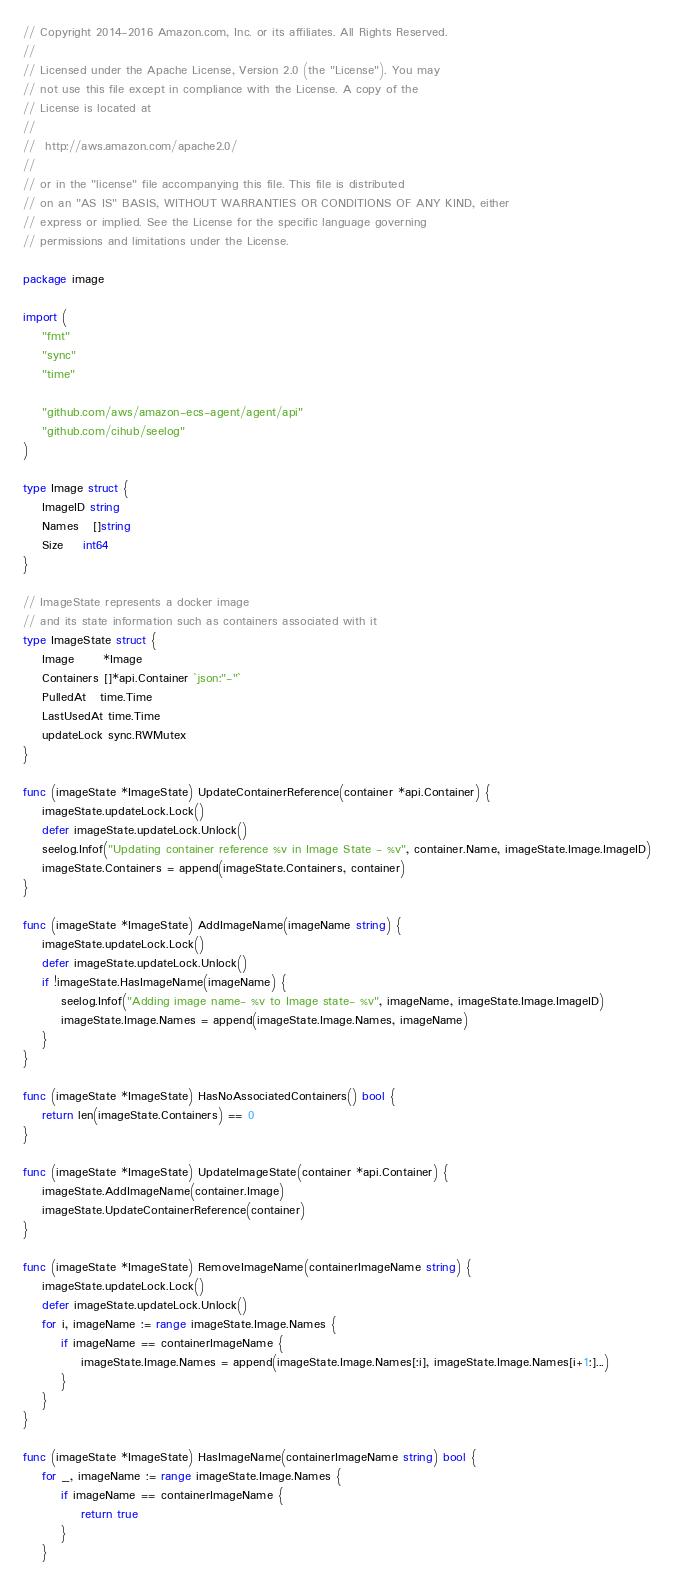Convert code to text. <code><loc_0><loc_0><loc_500><loc_500><_Go_>// Copyright 2014-2016 Amazon.com, Inc. or its affiliates. All Rights Reserved.
//
// Licensed under the Apache License, Version 2.0 (the "License"). You may
// not use this file except in compliance with the License. A copy of the
// License is located at
//
//	http://aws.amazon.com/apache2.0/
//
// or in the "license" file accompanying this file. This file is distributed
// on an "AS IS" BASIS, WITHOUT WARRANTIES OR CONDITIONS OF ANY KIND, either
// express or implied. See the License for the specific language governing
// permissions and limitations under the License.

package image

import (
	"fmt"
	"sync"
	"time"

	"github.com/aws/amazon-ecs-agent/agent/api"
	"github.com/cihub/seelog"
)

type Image struct {
	ImageID string
	Names   []string
	Size    int64
}

// ImageState represents a docker image
// and its state information such as containers associated with it
type ImageState struct {
	Image      *Image
	Containers []*api.Container `json:"-"`
	PulledAt   time.Time
	LastUsedAt time.Time
	updateLock sync.RWMutex
}

func (imageState *ImageState) UpdateContainerReference(container *api.Container) {
	imageState.updateLock.Lock()
	defer imageState.updateLock.Unlock()
	seelog.Infof("Updating container reference %v in Image State - %v", container.Name, imageState.Image.ImageID)
	imageState.Containers = append(imageState.Containers, container)
}

func (imageState *ImageState) AddImageName(imageName string) {
	imageState.updateLock.Lock()
	defer imageState.updateLock.Unlock()
	if !imageState.HasImageName(imageName) {
		seelog.Infof("Adding image name- %v to Image state- %v", imageName, imageState.Image.ImageID)
		imageState.Image.Names = append(imageState.Image.Names, imageName)
	}
}

func (imageState *ImageState) HasNoAssociatedContainers() bool {
	return len(imageState.Containers) == 0
}

func (imageState *ImageState) UpdateImageState(container *api.Container) {
	imageState.AddImageName(container.Image)
	imageState.UpdateContainerReference(container)
}

func (imageState *ImageState) RemoveImageName(containerImageName string) {
	imageState.updateLock.Lock()
	defer imageState.updateLock.Unlock()
	for i, imageName := range imageState.Image.Names {
		if imageName == containerImageName {
			imageState.Image.Names = append(imageState.Image.Names[:i], imageState.Image.Names[i+1:]...)
		}
	}
}

func (imageState *ImageState) HasImageName(containerImageName string) bool {
	for _, imageName := range imageState.Image.Names {
		if imageName == containerImageName {
			return true
		}
	}</code> 